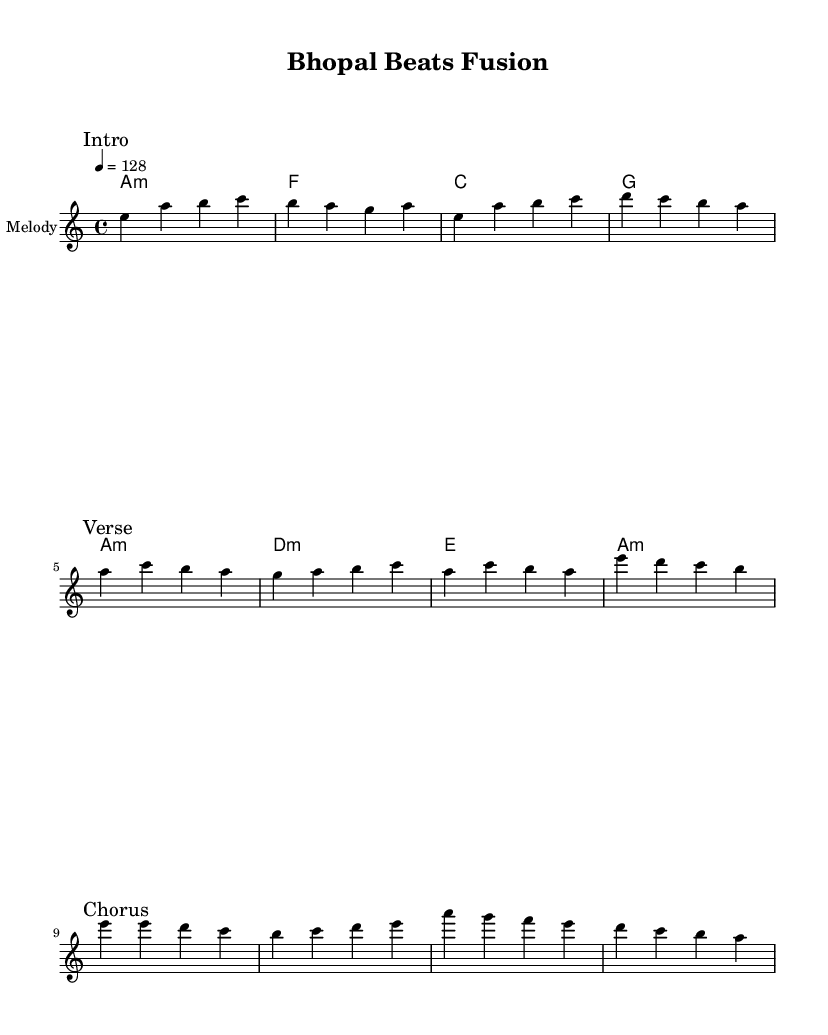What is the key signature of this music? The key signature is A minor, which has no sharps or flats.
Answer: A minor What is the time signature of this music? The time signature is indicated by the fraction shown at the beginning of the score, which is 4 over 4, meaning there are four beats in each measure.
Answer: 4/4 What is the tempo indicated in the music? The tempo is shown at the beginning of the score with a metronome marking of 128 beats per minute (4 = 128).
Answer: 128 How many sections are there in this piece? The piece contains three distinct sections indicated by markings: Intro, Verse, and Chorus. Each section is separated by a break.
Answer: 3 Which chord is played in the first measure? The first measure contains an A minor chord, indicated in the chord symbols provided above the staff.
Answer: A minor What is the main melodic note that starts the verse? The verse begins with the note A, which is the first note following the Intro section.
Answer: A What influences can be identified in this fusion piece? The fusion elements are derived from Bollywood-inspired electronic dance music combined with traditional Madhya Pradesh folk influences, which can be inferred from the style and structure of the music.
Answer: Bollywood and Madhya Pradesh folk 